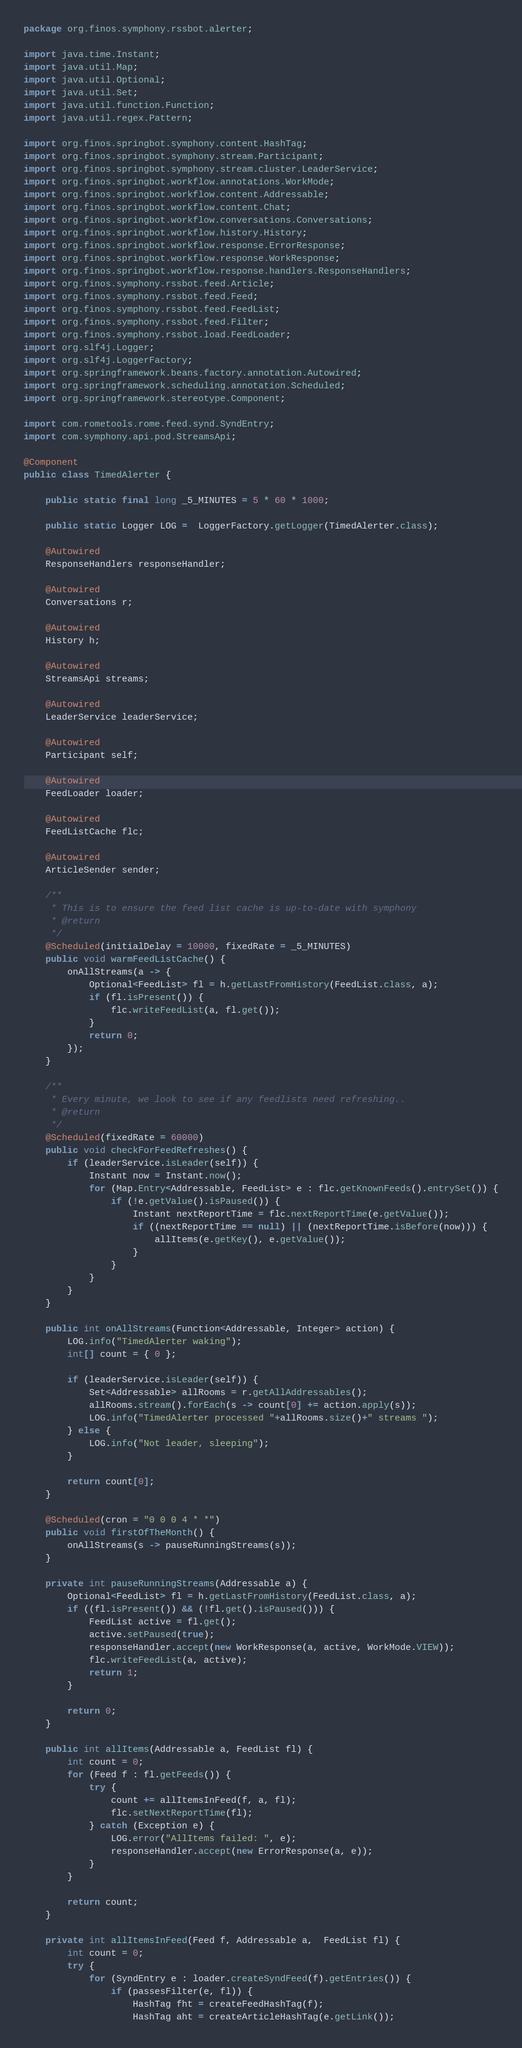<code> <loc_0><loc_0><loc_500><loc_500><_Java_>package org.finos.symphony.rssbot.alerter;

import java.time.Instant;
import java.util.Map;
import java.util.Optional;
import java.util.Set;
import java.util.function.Function;
import java.util.regex.Pattern;

import org.finos.springbot.symphony.content.HashTag;
import org.finos.springbot.symphony.stream.Participant;
import org.finos.springbot.symphony.stream.cluster.LeaderService;
import org.finos.springbot.workflow.annotations.WorkMode;
import org.finos.springbot.workflow.content.Addressable;
import org.finos.springbot.workflow.content.Chat;
import org.finos.springbot.workflow.conversations.Conversations;
import org.finos.springbot.workflow.history.History;
import org.finos.springbot.workflow.response.ErrorResponse;
import org.finos.springbot.workflow.response.WorkResponse;
import org.finos.springbot.workflow.response.handlers.ResponseHandlers;
import org.finos.symphony.rssbot.feed.Article;
import org.finos.symphony.rssbot.feed.Feed;
import org.finos.symphony.rssbot.feed.FeedList;
import org.finos.symphony.rssbot.feed.Filter;
import org.finos.symphony.rssbot.load.FeedLoader;
import org.slf4j.Logger;
import org.slf4j.LoggerFactory;
import org.springframework.beans.factory.annotation.Autowired;
import org.springframework.scheduling.annotation.Scheduled;
import org.springframework.stereotype.Component;

import com.rometools.rome.feed.synd.SyndEntry;
import com.symphony.api.pod.StreamsApi;

@Component
public class TimedAlerter {
	
	public static final long _5_MINUTES = 5 * 60 * 1000;
	
	public static Logger LOG =  LoggerFactory.getLogger(TimedAlerter.class);
		
	@Autowired
	ResponseHandlers responseHandler;
	
	@Autowired
	Conversations r;
	
	@Autowired
	History h;
	
	@Autowired
	StreamsApi streams;
	
	@Autowired
	LeaderService leaderService;
	
	@Autowired
	Participant self;
	
	@Autowired
	FeedLoader loader;
	
	@Autowired
	FeedListCache flc;
	
	@Autowired
	ArticleSender sender;
	
	/**
	 * This is to ensure the feed list cache is up-to-date with symphony
	 * @return
	 */
	@Scheduled(initialDelay = 10000, fixedRate = _5_MINUTES)
	public void warmFeedListCache() {
		onAllStreams(a -> {
			Optional<FeedList> fl = h.getLastFromHistory(FeedList.class, a); 
			if (fl.isPresent()) {
				flc.writeFeedList(a, fl.get());
			}		
			return 0;
		});
	}
	
	/**
	 * Every minute, we look to see if any feedlists need refreshing..
	 * @return
	 */
	@Scheduled(fixedRate = 60000)
	public void checkForFeedRefreshes() {
		if (leaderService.isLeader(self)) {
			Instant now = Instant.now();
			for (Map.Entry<Addressable, FeedList> e : flc.getKnownFeeds().entrySet()) {
				if (!e.getValue().isPaused()) {
					Instant nextReportTime = flc.nextReportTime(e.getValue());
					if ((nextReportTime == null) || (nextReportTime.isBefore(now))) {
						allItems(e.getKey(), e.getValue());
					}
				}
			}
		}
	}

	public int onAllStreams(Function<Addressable, Integer> action) {
		LOG.info("TimedAlerter waking");
		int[] count = { 0 };

		if (leaderService.isLeader(self)) {
			Set<Addressable> allRooms = r.getAllAddressables();
			allRooms.stream().forEach(s -> count[0] += action.apply(s));
			LOG.info("TimedAlerter processed "+allRooms.size()+" streams ");
		} else {
			LOG.info("Not leader, sleeping");
		}
		
		return count[0];
	}
	
	@Scheduled(cron = "0 0 0 4 * *")
	public void firstOfTheMonth() {
		onAllStreams(s -> pauseRunningStreams(s));
	}

	private int pauseRunningStreams(Addressable a) {
		Optional<FeedList> fl = h.getLastFromHistory(FeedList.class, a); 
		if ((fl.isPresent()) && (!fl.get().isPaused())) {
			FeedList active = fl.get();
			active.setPaused(true);
			responseHandler.accept(new WorkResponse(a, active, WorkMode.VIEW));
			flc.writeFeedList(a, active);
			return 1;
		}
		
		return 0;
	}

	public int allItems(Addressable a, FeedList fl) {
		int count = 0;
		for (Feed f : fl.getFeeds()) {
			try {
				count += allItemsInFeed(f, a, fl);
				flc.setNextReportTime(fl);
			} catch (Exception e) {
				LOG.error("AllItems failed: ", e);
				responseHandler.accept(new ErrorResponse(a, e));
			}
		}
		
		return count;
	}

	private int allItemsInFeed(Feed f, Addressable a,  FeedList fl) {
		int count = 0;
		try {
			for (SyndEntry e : loader.createSyndFeed(f).getEntries()) {
				if (passesFilter(e, fl)) {
					HashTag fht = createFeedHashTag(f);
					HashTag aht = createArticleHashTag(e.getLink());</code> 